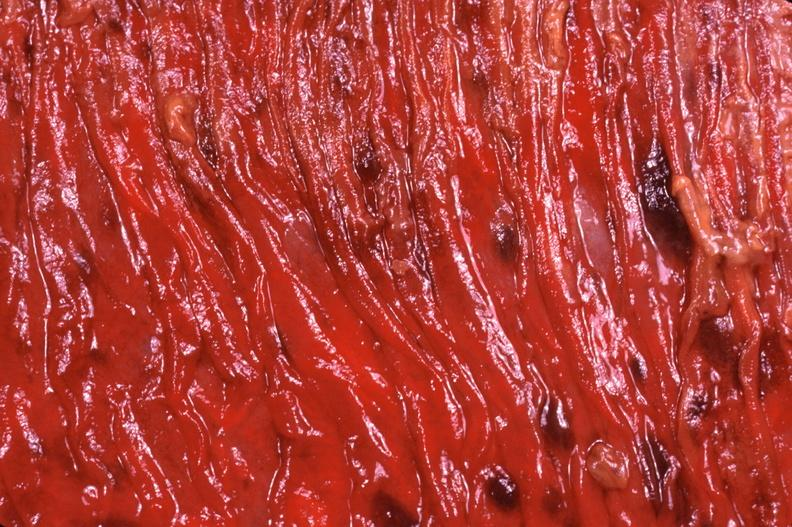does this image show duodenum, necrotizing enteritis with pseudomembrane, candida?
Answer the question using a single word or phrase. Yes 